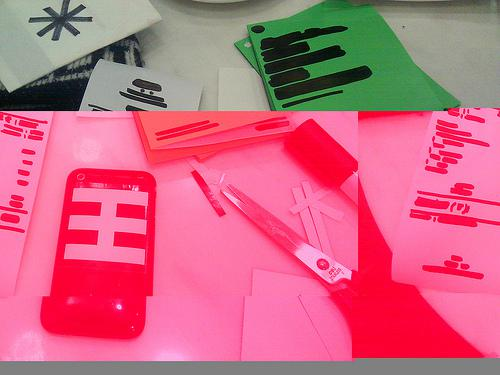Question: what color are the bottom photos?
Choices:
A. Yellow.
B. Pink.
C. Green.
D. Purple.
Answer with the letter. Answer: B Question: who is in this photo?
Choices:
A. Mom.
B. Dad.
C. Grandma.
D. Nobody.
Answer with the letter. Answer: D Question: how many lines are crossed out on the green paper?
Choices:
A. Four.
B. Six.
C. Three.
D. One.
Answer with the letter. Answer: B Question: where are the scissors?
Choices:
A. In the drawer.
B. In the bottom right of the bottom left two photos.
C. On the table.
D. In the basket.
Answer with the letter. Answer: B Question: what is to the left of the scissors?
Choices:
A. A cell phone.
B. Remote.
C. Cup of water.
D. Magazine.
Answer with the letter. Answer: A Question: how many small strips of paper are to the right of the scissors?
Choices:
A. Six.
B. Two.
C. Four.
D. Three.
Answer with the letter. Answer: C Question: what is drawn on the top left paper?
Choices:
A. An asterix.
B. A star.
C. A smiley face.
D. A sad face.
Answer with the letter. Answer: A 